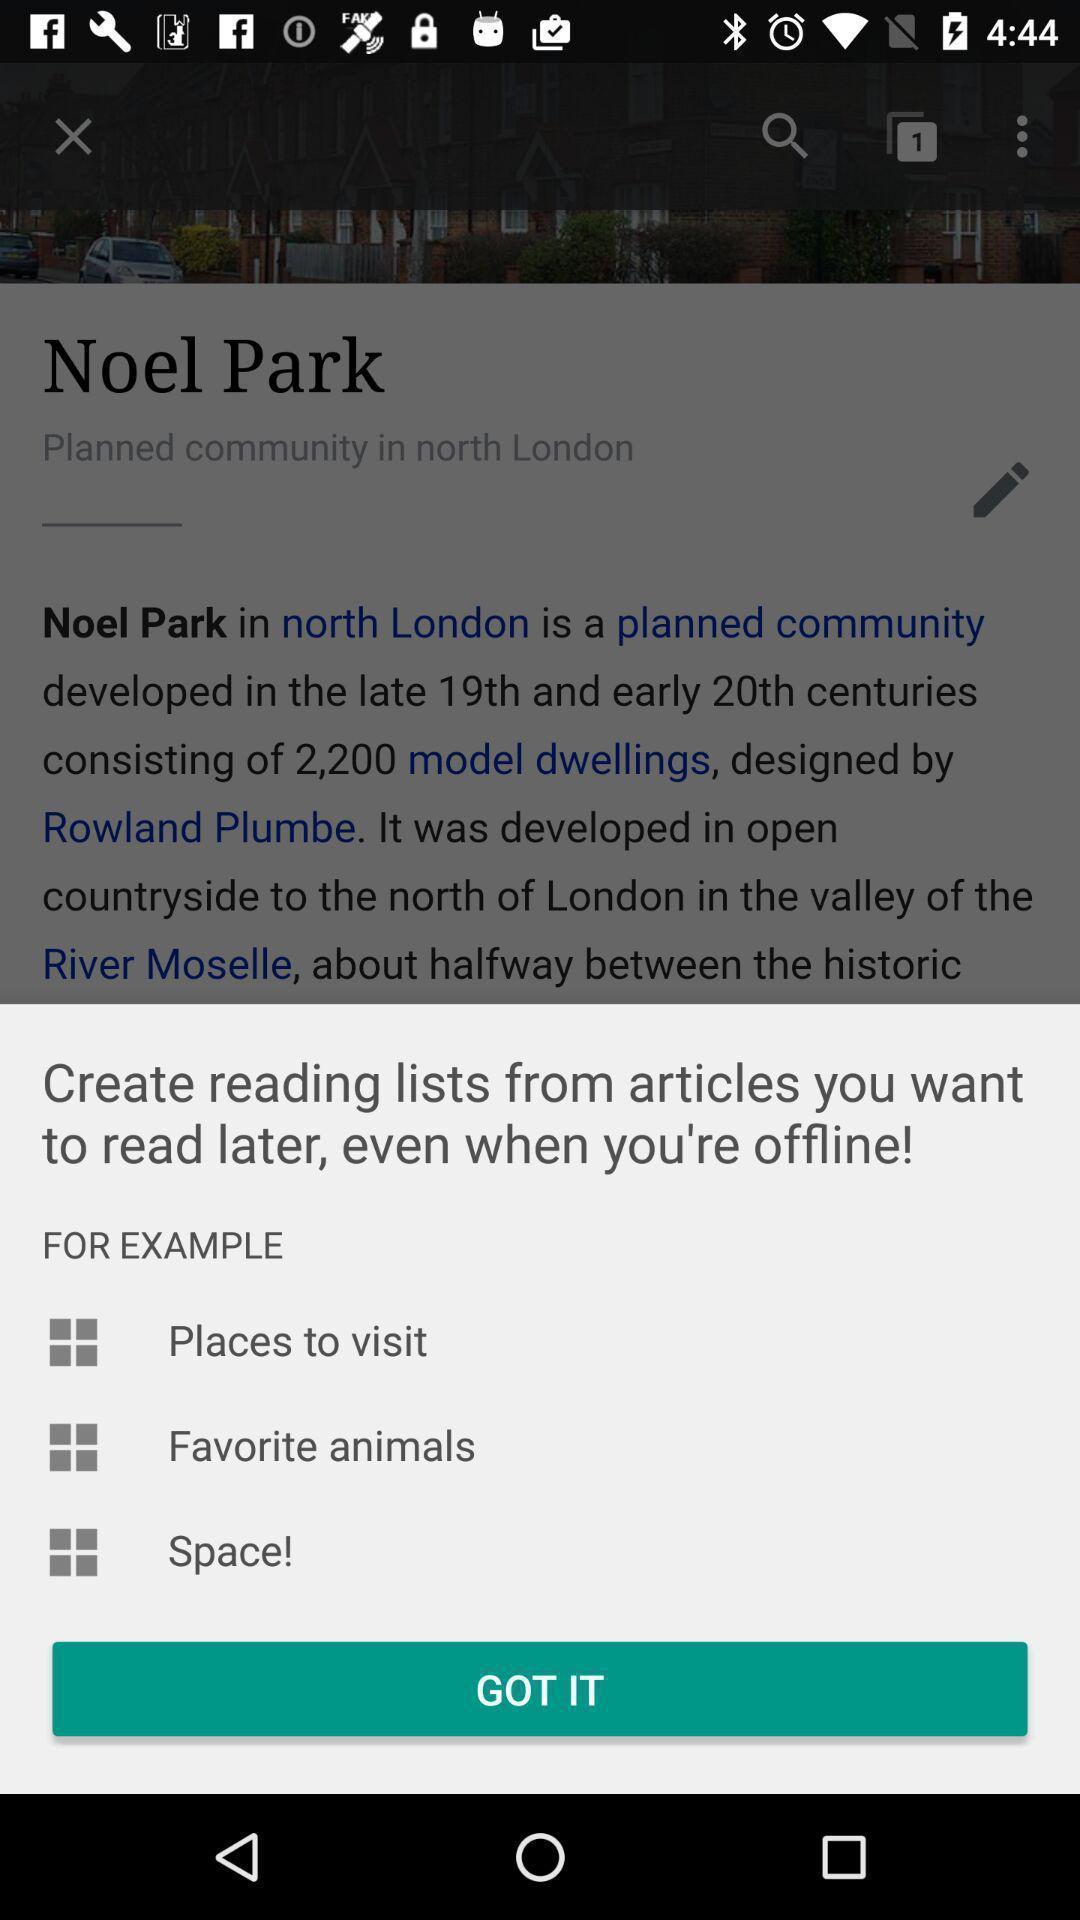Provide a description of this screenshot. Popup showing few information. 